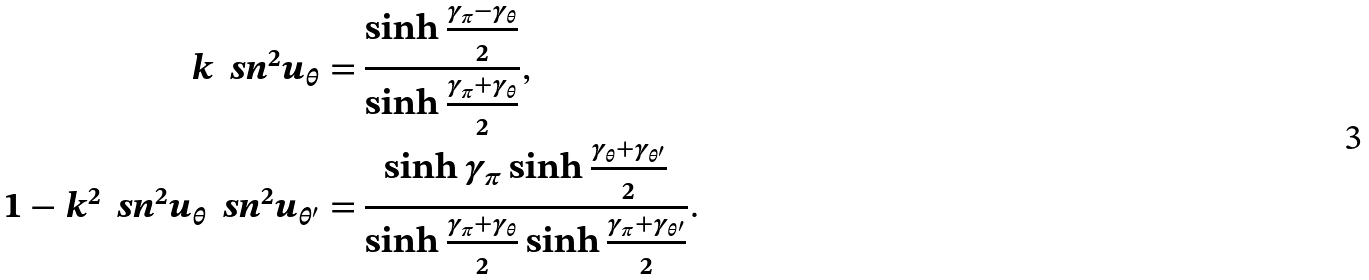<formula> <loc_0><loc_0><loc_500><loc_500>k \, \ s n ^ { 2 } u _ { \theta } = & \, \frac { \sinh \frac { \gamma _ { \pi } - \gamma _ { \theta } } { 2 } } { \sinh \frac { \gamma _ { \pi } + \gamma _ { \theta } } { 2 } } , \\ 1 - k ^ { 2 } \, \ s n ^ { 2 } u _ { \theta } \, \ s n ^ { 2 } u _ { \theta ^ { \prime } } = & \, \frac { \sinh \gamma _ { \pi } \sinh \frac { \gamma _ { \theta } + \gamma _ { \theta ^ { \prime } } } { 2 } } { \sinh \frac { \gamma _ { \pi } + \gamma _ { \theta } } { 2 } \sinh \frac { \gamma _ { \pi } + \gamma _ { \theta ^ { \prime } } } { 2 } } .</formula> 